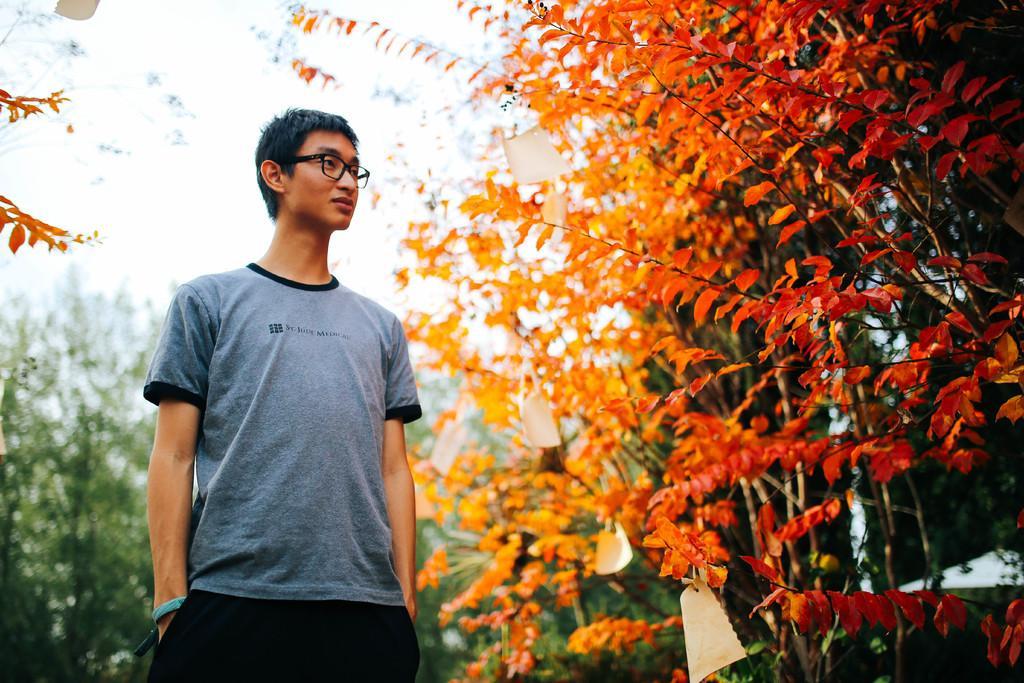In one or two sentences, can you explain what this image depicts? In the left side a man is standing, he wore a t-shirt and a black color spectacles. In the right side there are plants. 